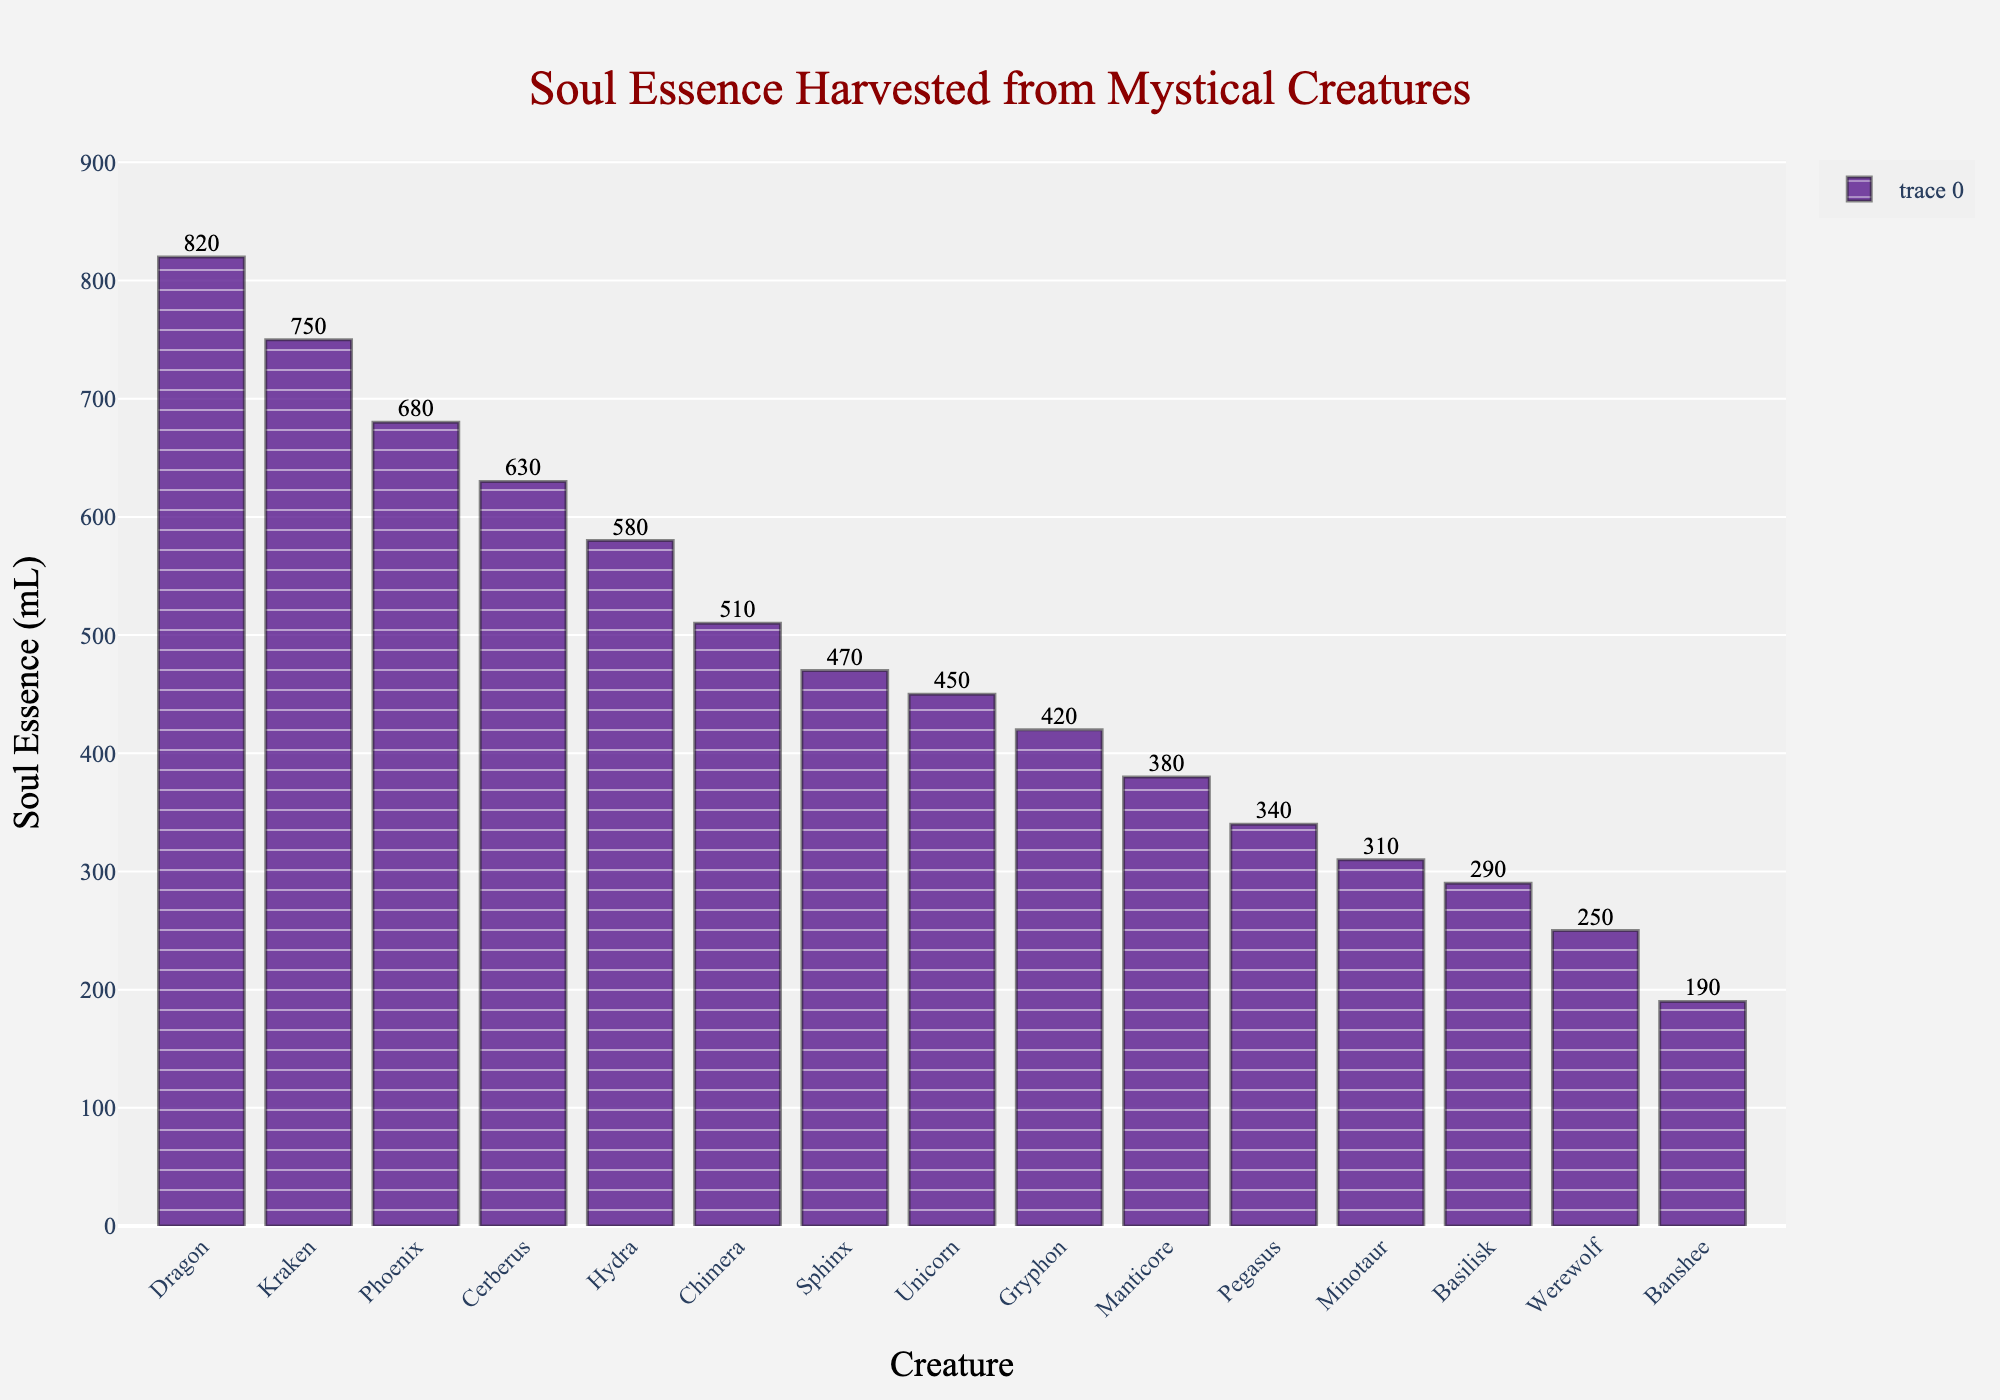Which creature has the highest amount of soul essence harvested? The tallest bar represents the creature with the highest amount of soul essence. In this case, it's the Dragon with 820 mL.
Answer: Dragon Which creature has the least amount of soul essence harvested? The shortest bar represents the creature with the least amount of soul essence. In this case, it's the Banshee with 190 mL.
Answer: Banshee What's the total amount of soul essence harvested from the Kraken and the Phoenix? Add the soul essence amounts from Kraken (750 mL) and Phoenix (680 mL). 750 + 680 = 1430 mL.
Answer: 1430 mL Is the soul essence harvested from a Unicorn greater than that from a Pegasus? Compare the heights of the bars for Unicorn (450 mL) and Pegasus (340 mL). The bar representing the Unicorn is taller. 450 is greater than 340.
Answer: Yes How much more soul essence is harvested from a Dragon compared to a Basilisk? Subtract the soul essence of Basilisk (290 mL) from that of Dragon (820 mL). 820 - 290 = 530 mL.
Answer: 530 mL What's the average amount of soul essence harvested from a Werewolf, Minotaur, and Manticore? Sum the soul essence amounts from Werewolf (250 mL), Minotaur (310 mL), and Manticore (380 mL) and divide by 3. (250 + 310 + 380) / 3 = 940 / 3 ≈ 313.33 mL.
Answer: ≈ 313.33 mL Which creatures have more than 600 mL of soul essence harvested? Identify all bars with values greater than 600 mL: Phoenix (680 mL), Dragon (820 mL), Kraken (750 mL), and Cerberus (630 mL).
Answer: Phoenix, Dragon, Kraken, Cerberus Are there more creatures with less than 400 mL or more than 400 mL of soul essence harvested? Count the bars less than and more than 400 mL. Less than 400 mL: Basilisk, Manticore, Banshee, Pegasus, Werewolf, Minotaur (6 creatures). More than 400 mL: Unicorn, Phoenix, Dragon, Chimera, Kraken, Gryphon, Cerberus, Hydra, Sphinx (9 creatures). Thus, more creatures have greater than 400 mL.
Answer: More What's the median amount of soul essence harvested across all creatures? Sort all values and find the middle one. Sorted values: [190, 250, 290, 310, 340, 380, 420, 450, 470, 510, 580, 630, 680, 750, 820]. The middle value (8th) is 450 mL.
Answer: 450 mL 